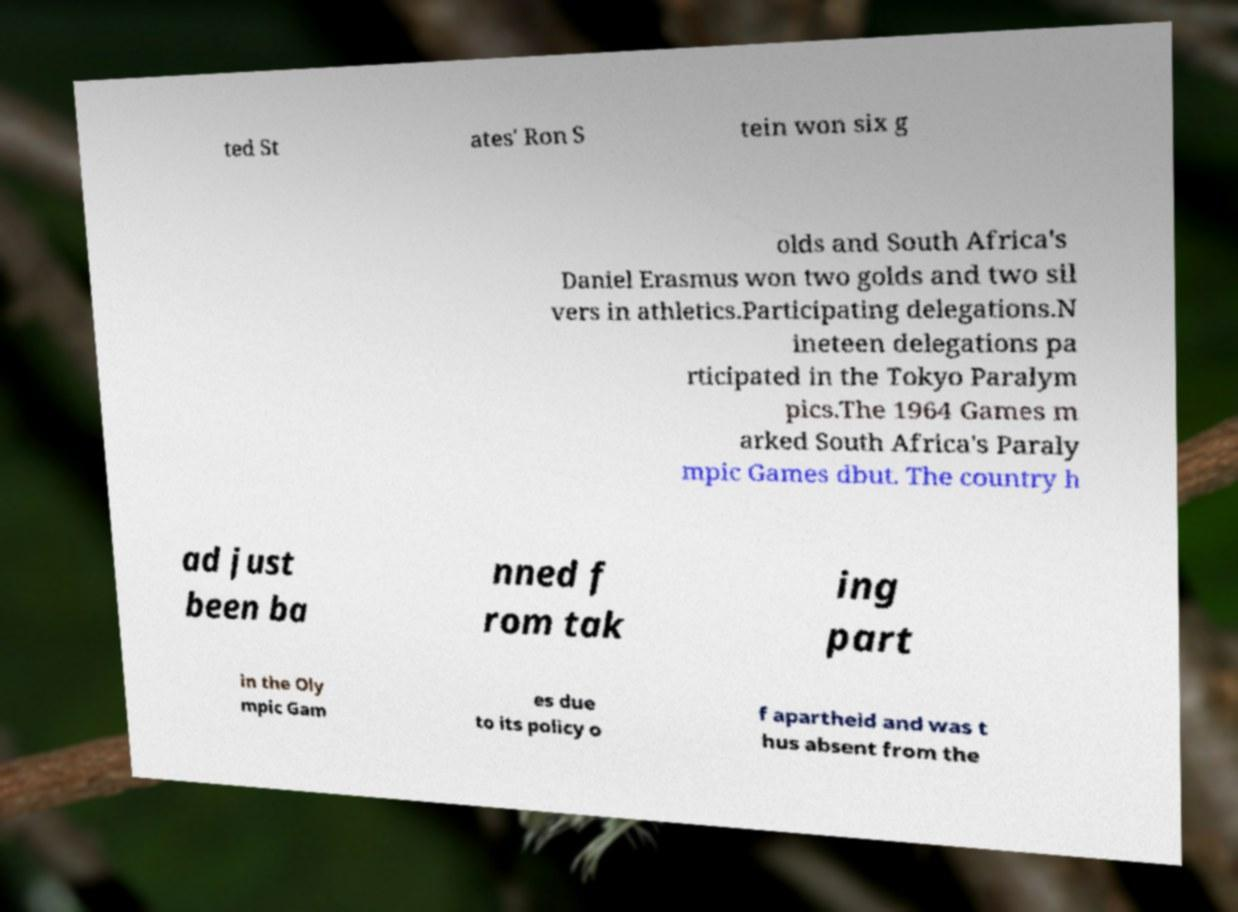Can you accurately transcribe the text from the provided image for me? ted St ates' Ron S tein won six g olds and South Africa's Daniel Erasmus won two golds and two sil vers in athletics.Participating delegations.N ineteen delegations pa rticipated in the Tokyo Paralym pics.The 1964 Games m arked South Africa's Paraly mpic Games dbut. The country h ad just been ba nned f rom tak ing part in the Oly mpic Gam es due to its policy o f apartheid and was t hus absent from the 